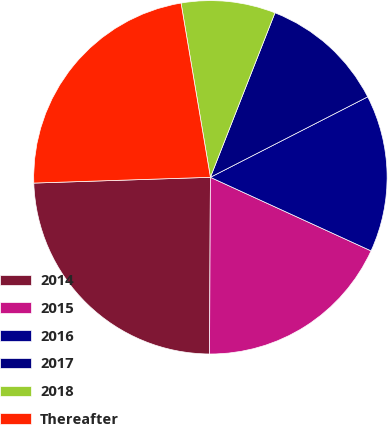Convert chart. <chart><loc_0><loc_0><loc_500><loc_500><pie_chart><fcel>2014<fcel>2015<fcel>2016<fcel>2017<fcel>2018<fcel>Thereafter<nl><fcel>24.4%<fcel>18.24%<fcel>14.36%<fcel>11.52%<fcel>8.61%<fcel>22.86%<nl></chart> 